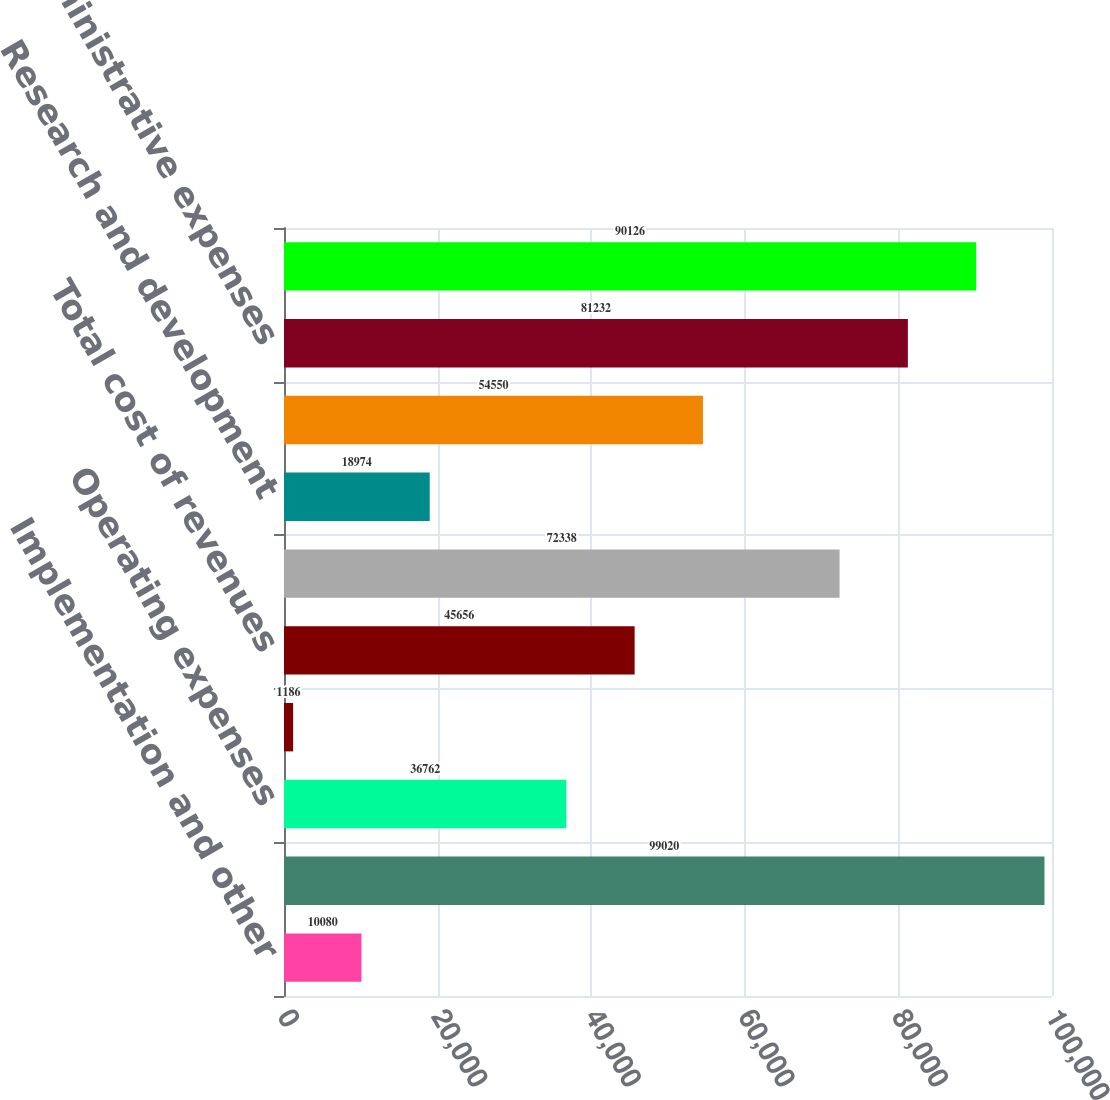Convert chart to OTSL. <chart><loc_0><loc_0><loc_500><loc_500><bar_chart><fcel>Implementation and other<fcel>Total revenues<fcel>Operating expenses<fcel>Depreciation and amortization<fcel>Total cost of revenues<fcel>Sales and marketing<fcel>Research and development<fcel>General and administrative<fcel>Total administrative expenses<fcel>Total operating expenses<nl><fcel>10080<fcel>99020<fcel>36762<fcel>1186<fcel>45656<fcel>72338<fcel>18974<fcel>54550<fcel>81232<fcel>90126<nl></chart> 